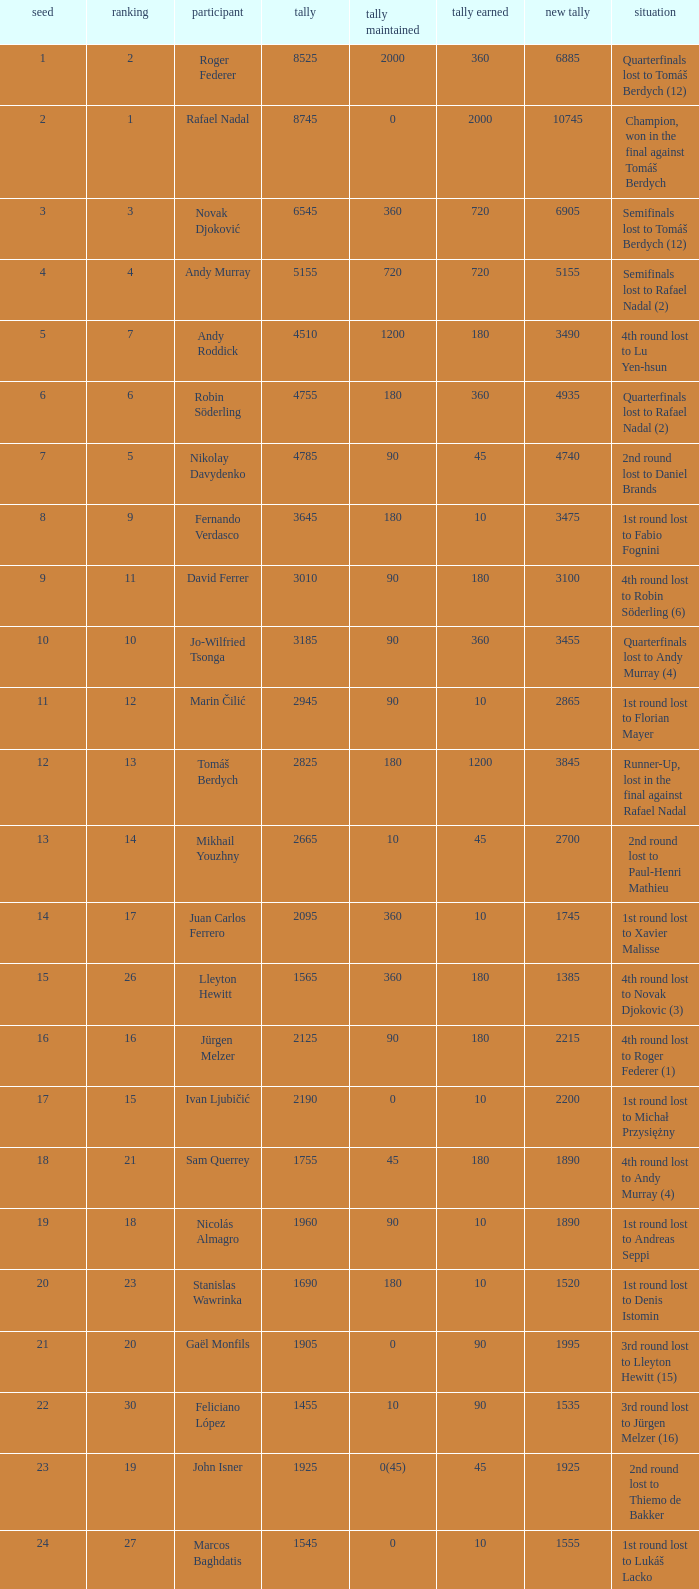Name the number of points defending for 1075 1.0. 